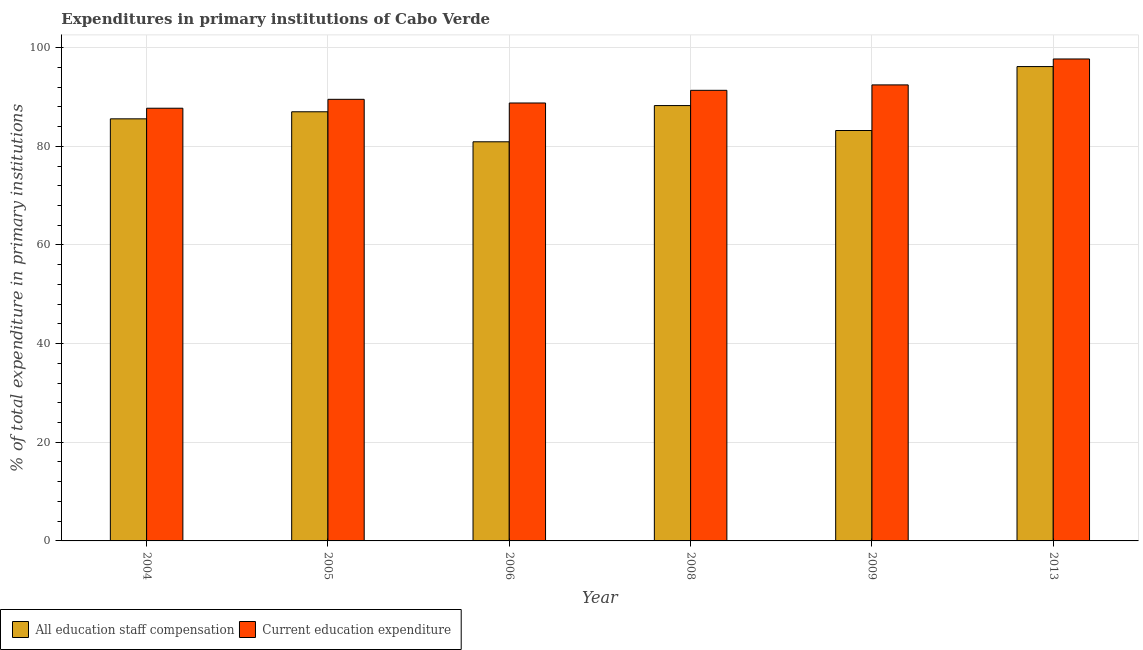How many groups of bars are there?
Your response must be concise. 6. How many bars are there on the 1st tick from the left?
Keep it short and to the point. 2. How many bars are there on the 6th tick from the right?
Make the answer very short. 2. What is the expenditure in staff compensation in 2006?
Your answer should be compact. 80.91. Across all years, what is the maximum expenditure in education?
Your response must be concise. 97.7. Across all years, what is the minimum expenditure in staff compensation?
Your answer should be very brief. 80.91. In which year was the expenditure in education maximum?
Your answer should be compact. 2013. In which year was the expenditure in education minimum?
Ensure brevity in your answer.  2004. What is the total expenditure in staff compensation in the graph?
Ensure brevity in your answer.  521.1. What is the difference between the expenditure in education in 2006 and that in 2013?
Offer a terse response. -8.92. What is the difference between the expenditure in staff compensation in 2006 and the expenditure in education in 2009?
Keep it short and to the point. -2.29. What is the average expenditure in education per year?
Keep it short and to the point. 91.25. In the year 2009, what is the difference between the expenditure in staff compensation and expenditure in education?
Provide a succinct answer. 0. What is the ratio of the expenditure in staff compensation in 2004 to that in 2006?
Your answer should be very brief. 1.06. Is the expenditure in education in 2008 less than that in 2013?
Give a very brief answer. Yes. Is the difference between the expenditure in staff compensation in 2004 and 2008 greater than the difference between the expenditure in education in 2004 and 2008?
Provide a succinct answer. No. What is the difference between the highest and the second highest expenditure in education?
Ensure brevity in your answer.  5.26. What is the difference between the highest and the lowest expenditure in education?
Provide a succinct answer. 9.98. Is the sum of the expenditure in staff compensation in 2009 and 2013 greater than the maximum expenditure in education across all years?
Your response must be concise. Yes. What does the 2nd bar from the left in 2013 represents?
Your answer should be compact. Current education expenditure. What does the 1st bar from the right in 2008 represents?
Offer a terse response. Current education expenditure. How many bars are there?
Provide a short and direct response. 12. How many years are there in the graph?
Provide a succinct answer. 6. What is the difference between two consecutive major ticks on the Y-axis?
Provide a short and direct response. 20. Does the graph contain any zero values?
Your answer should be compact. No. Does the graph contain grids?
Your answer should be compact. Yes. How many legend labels are there?
Your response must be concise. 2. What is the title of the graph?
Keep it short and to the point. Expenditures in primary institutions of Cabo Verde. Does "Agricultural land" appear as one of the legend labels in the graph?
Offer a very short reply. No. What is the label or title of the Y-axis?
Offer a very short reply. % of total expenditure in primary institutions. What is the % of total expenditure in primary institutions in All education staff compensation in 2004?
Make the answer very short. 85.57. What is the % of total expenditure in primary institutions in Current education expenditure in 2004?
Keep it short and to the point. 87.72. What is the % of total expenditure in primary institutions in All education staff compensation in 2005?
Offer a terse response. 87. What is the % of total expenditure in primary institutions in Current education expenditure in 2005?
Provide a short and direct response. 89.52. What is the % of total expenditure in primary institutions of All education staff compensation in 2006?
Keep it short and to the point. 80.91. What is the % of total expenditure in primary institutions of Current education expenditure in 2006?
Your response must be concise. 88.78. What is the % of total expenditure in primary institutions in All education staff compensation in 2008?
Ensure brevity in your answer.  88.26. What is the % of total expenditure in primary institutions in Current education expenditure in 2008?
Ensure brevity in your answer.  91.35. What is the % of total expenditure in primary institutions in All education staff compensation in 2009?
Your response must be concise. 83.2. What is the % of total expenditure in primary institutions in Current education expenditure in 2009?
Your answer should be very brief. 92.45. What is the % of total expenditure in primary institutions of All education staff compensation in 2013?
Your answer should be very brief. 96.16. What is the % of total expenditure in primary institutions in Current education expenditure in 2013?
Give a very brief answer. 97.7. Across all years, what is the maximum % of total expenditure in primary institutions of All education staff compensation?
Make the answer very short. 96.16. Across all years, what is the maximum % of total expenditure in primary institutions in Current education expenditure?
Offer a very short reply. 97.7. Across all years, what is the minimum % of total expenditure in primary institutions of All education staff compensation?
Your answer should be compact. 80.91. Across all years, what is the minimum % of total expenditure in primary institutions in Current education expenditure?
Your response must be concise. 87.72. What is the total % of total expenditure in primary institutions in All education staff compensation in the graph?
Your answer should be compact. 521.1. What is the total % of total expenditure in primary institutions of Current education expenditure in the graph?
Provide a short and direct response. 547.52. What is the difference between the % of total expenditure in primary institutions in All education staff compensation in 2004 and that in 2005?
Your answer should be very brief. -1.43. What is the difference between the % of total expenditure in primary institutions in Current education expenditure in 2004 and that in 2005?
Provide a short and direct response. -1.8. What is the difference between the % of total expenditure in primary institutions in All education staff compensation in 2004 and that in 2006?
Provide a short and direct response. 4.65. What is the difference between the % of total expenditure in primary institutions in Current education expenditure in 2004 and that in 2006?
Keep it short and to the point. -1.06. What is the difference between the % of total expenditure in primary institutions of All education staff compensation in 2004 and that in 2008?
Make the answer very short. -2.69. What is the difference between the % of total expenditure in primary institutions of Current education expenditure in 2004 and that in 2008?
Ensure brevity in your answer.  -3.63. What is the difference between the % of total expenditure in primary institutions of All education staff compensation in 2004 and that in 2009?
Offer a terse response. 2.37. What is the difference between the % of total expenditure in primary institutions of Current education expenditure in 2004 and that in 2009?
Your response must be concise. -4.73. What is the difference between the % of total expenditure in primary institutions of All education staff compensation in 2004 and that in 2013?
Provide a short and direct response. -10.6. What is the difference between the % of total expenditure in primary institutions in Current education expenditure in 2004 and that in 2013?
Provide a short and direct response. -9.98. What is the difference between the % of total expenditure in primary institutions of All education staff compensation in 2005 and that in 2006?
Make the answer very short. 6.09. What is the difference between the % of total expenditure in primary institutions in Current education expenditure in 2005 and that in 2006?
Provide a short and direct response. 0.74. What is the difference between the % of total expenditure in primary institutions in All education staff compensation in 2005 and that in 2008?
Offer a very short reply. -1.26. What is the difference between the % of total expenditure in primary institutions in Current education expenditure in 2005 and that in 2008?
Provide a succinct answer. -1.83. What is the difference between the % of total expenditure in primary institutions of All education staff compensation in 2005 and that in 2009?
Ensure brevity in your answer.  3.8. What is the difference between the % of total expenditure in primary institutions in Current education expenditure in 2005 and that in 2009?
Provide a succinct answer. -2.92. What is the difference between the % of total expenditure in primary institutions of All education staff compensation in 2005 and that in 2013?
Keep it short and to the point. -9.16. What is the difference between the % of total expenditure in primary institutions of Current education expenditure in 2005 and that in 2013?
Make the answer very short. -8.18. What is the difference between the % of total expenditure in primary institutions of All education staff compensation in 2006 and that in 2008?
Ensure brevity in your answer.  -7.34. What is the difference between the % of total expenditure in primary institutions in Current education expenditure in 2006 and that in 2008?
Offer a terse response. -2.57. What is the difference between the % of total expenditure in primary institutions in All education staff compensation in 2006 and that in 2009?
Offer a very short reply. -2.29. What is the difference between the % of total expenditure in primary institutions in Current education expenditure in 2006 and that in 2009?
Give a very brief answer. -3.67. What is the difference between the % of total expenditure in primary institutions of All education staff compensation in 2006 and that in 2013?
Ensure brevity in your answer.  -15.25. What is the difference between the % of total expenditure in primary institutions of Current education expenditure in 2006 and that in 2013?
Provide a succinct answer. -8.92. What is the difference between the % of total expenditure in primary institutions in All education staff compensation in 2008 and that in 2009?
Give a very brief answer. 5.06. What is the difference between the % of total expenditure in primary institutions of Current education expenditure in 2008 and that in 2009?
Offer a terse response. -1.1. What is the difference between the % of total expenditure in primary institutions of All education staff compensation in 2008 and that in 2013?
Make the answer very short. -7.91. What is the difference between the % of total expenditure in primary institutions in Current education expenditure in 2008 and that in 2013?
Keep it short and to the point. -6.35. What is the difference between the % of total expenditure in primary institutions of All education staff compensation in 2009 and that in 2013?
Ensure brevity in your answer.  -12.96. What is the difference between the % of total expenditure in primary institutions in Current education expenditure in 2009 and that in 2013?
Keep it short and to the point. -5.26. What is the difference between the % of total expenditure in primary institutions of All education staff compensation in 2004 and the % of total expenditure in primary institutions of Current education expenditure in 2005?
Your answer should be very brief. -3.96. What is the difference between the % of total expenditure in primary institutions of All education staff compensation in 2004 and the % of total expenditure in primary institutions of Current education expenditure in 2006?
Your response must be concise. -3.21. What is the difference between the % of total expenditure in primary institutions of All education staff compensation in 2004 and the % of total expenditure in primary institutions of Current education expenditure in 2008?
Make the answer very short. -5.78. What is the difference between the % of total expenditure in primary institutions of All education staff compensation in 2004 and the % of total expenditure in primary institutions of Current education expenditure in 2009?
Your response must be concise. -6.88. What is the difference between the % of total expenditure in primary institutions in All education staff compensation in 2004 and the % of total expenditure in primary institutions in Current education expenditure in 2013?
Offer a very short reply. -12.14. What is the difference between the % of total expenditure in primary institutions of All education staff compensation in 2005 and the % of total expenditure in primary institutions of Current education expenditure in 2006?
Offer a very short reply. -1.78. What is the difference between the % of total expenditure in primary institutions in All education staff compensation in 2005 and the % of total expenditure in primary institutions in Current education expenditure in 2008?
Offer a very short reply. -4.35. What is the difference between the % of total expenditure in primary institutions in All education staff compensation in 2005 and the % of total expenditure in primary institutions in Current education expenditure in 2009?
Offer a very short reply. -5.45. What is the difference between the % of total expenditure in primary institutions in All education staff compensation in 2005 and the % of total expenditure in primary institutions in Current education expenditure in 2013?
Give a very brief answer. -10.7. What is the difference between the % of total expenditure in primary institutions of All education staff compensation in 2006 and the % of total expenditure in primary institutions of Current education expenditure in 2008?
Provide a succinct answer. -10.44. What is the difference between the % of total expenditure in primary institutions of All education staff compensation in 2006 and the % of total expenditure in primary institutions of Current education expenditure in 2009?
Give a very brief answer. -11.53. What is the difference between the % of total expenditure in primary institutions in All education staff compensation in 2006 and the % of total expenditure in primary institutions in Current education expenditure in 2013?
Make the answer very short. -16.79. What is the difference between the % of total expenditure in primary institutions of All education staff compensation in 2008 and the % of total expenditure in primary institutions of Current education expenditure in 2009?
Your answer should be compact. -4.19. What is the difference between the % of total expenditure in primary institutions in All education staff compensation in 2008 and the % of total expenditure in primary institutions in Current education expenditure in 2013?
Your response must be concise. -9.45. What is the difference between the % of total expenditure in primary institutions in All education staff compensation in 2009 and the % of total expenditure in primary institutions in Current education expenditure in 2013?
Offer a very short reply. -14.5. What is the average % of total expenditure in primary institutions in All education staff compensation per year?
Provide a succinct answer. 86.85. What is the average % of total expenditure in primary institutions of Current education expenditure per year?
Ensure brevity in your answer.  91.25. In the year 2004, what is the difference between the % of total expenditure in primary institutions in All education staff compensation and % of total expenditure in primary institutions in Current education expenditure?
Your answer should be compact. -2.15. In the year 2005, what is the difference between the % of total expenditure in primary institutions in All education staff compensation and % of total expenditure in primary institutions in Current education expenditure?
Offer a terse response. -2.52. In the year 2006, what is the difference between the % of total expenditure in primary institutions of All education staff compensation and % of total expenditure in primary institutions of Current education expenditure?
Your response must be concise. -7.87. In the year 2008, what is the difference between the % of total expenditure in primary institutions of All education staff compensation and % of total expenditure in primary institutions of Current education expenditure?
Keep it short and to the point. -3.09. In the year 2009, what is the difference between the % of total expenditure in primary institutions in All education staff compensation and % of total expenditure in primary institutions in Current education expenditure?
Offer a terse response. -9.24. In the year 2013, what is the difference between the % of total expenditure in primary institutions in All education staff compensation and % of total expenditure in primary institutions in Current education expenditure?
Ensure brevity in your answer.  -1.54. What is the ratio of the % of total expenditure in primary institutions of All education staff compensation in 2004 to that in 2005?
Provide a succinct answer. 0.98. What is the ratio of the % of total expenditure in primary institutions of Current education expenditure in 2004 to that in 2005?
Offer a terse response. 0.98. What is the ratio of the % of total expenditure in primary institutions of All education staff compensation in 2004 to that in 2006?
Keep it short and to the point. 1.06. What is the ratio of the % of total expenditure in primary institutions of All education staff compensation in 2004 to that in 2008?
Your answer should be very brief. 0.97. What is the ratio of the % of total expenditure in primary institutions in Current education expenditure in 2004 to that in 2008?
Your response must be concise. 0.96. What is the ratio of the % of total expenditure in primary institutions of All education staff compensation in 2004 to that in 2009?
Your answer should be very brief. 1.03. What is the ratio of the % of total expenditure in primary institutions in Current education expenditure in 2004 to that in 2009?
Your response must be concise. 0.95. What is the ratio of the % of total expenditure in primary institutions in All education staff compensation in 2004 to that in 2013?
Provide a succinct answer. 0.89. What is the ratio of the % of total expenditure in primary institutions in Current education expenditure in 2004 to that in 2013?
Make the answer very short. 0.9. What is the ratio of the % of total expenditure in primary institutions in All education staff compensation in 2005 to that in 2006?
Provide a succinct answer. 1.08. What is the ratio of the % of total expenditure in primary institutions in Current education expenditure in 2005 to that in 2006?
Your answer should be very brief. 1.01. What is the ratio of the % of total expenditure in primary institutions of All education staff compensation in 2005 to that in 2008?
Provide a short and direct response. 0.99. What is the ratio of the % of total expenditure in primary institutions in Current education expenditure in 2005 to that in 2008?
Your answer should be compact. 0.98. What is the ratio of the % of total expenditure in primary institutions of All education staff compensation in 2005 to that in 2009?
Ensure brevity in your answer.  1.05. What is the ratio of the % of total expenditure in primary institutions of Current education expenditure in 2005 to that in 2009?
Your response must be concise. 0.97. What is the ratio of the % of total expenditure in primary institutions of All education staff compensation in 2005 to that in 2013?
Offer a terse response. 0.9. What is the ratio of the % of total expenditure in primary institutions of Current education expenditure in 2005 to that in 2013?
Make the answer very short. 0.92. What is the ratio of the % of total expenditure in primary institutions in All education staff compensation in 2006 to that in 2008?
Provide a short and direct response. 0.92. What is the ratio of the % of total expenditure in primary institutions of Current education expenditure in 2006 to that in 2008?
Keep it short and to the point. 0.97. What is the ratio of the % of total expenditure in primary institutions in All education staff compensation in 2006 to that in 2009?
Your answer should be compact. 0.97. What is the ratio of the % of total expenditure in primary institutions in Current education expenditure in 2006 to that in 2009?
Provide a succinct answer. 0.96. What is the ratio of the % of total expenditure in primary institutions of All education staff compensation in 2006 to that in 2013?
Your answer should be very brief. 0.84. What is the ratio of the % of total expenditure in primary institutions of Current education expenditure in 2006 to that in 2013?
Ensure brevity in your answer.  0.91. What is the ratio of the % of total expenditure in primary institutions of All education staff compensation in 2008 to that in 2009?
Your response must be concise. 1.06. What is the ratio of the % of total expenditure in primary institutions of Current education expenditure in 2008 to that in 2009?
Provide a succinct answer. 0.99. What is the ratio of the % of total expenditure in primary institutions in All education staff compensation in 2008 to that in 2013?
Offer a very short reply. 0.92. What is the ratio of the % of total expenditure in primary institutions of Current education expenditure in 2008 to that in 2013?
Your answer should be compact. 0.94. What is the ratio of the % of total expenditure in primary institutions of All education staff compensation in 2009 to that in 2013?
Provide a succinct answer. 0.87. What is the ratio of the % of total expenditure in primary institutions in Current education expenditure in 2009 to that in 2013?
Your answer should be compact. 0.95. What is the difference between the highest and the second highest % of total expenditure in primary institutions of All education staff compensation?
Your answer should be very brief. 7.91. What is the difference between the highest and the second highest % of total expenditure in primary institutions in Current education expenditure?
Provide a short and direct response. 5.26. What is the difference between the highest and the lowest % of total expenditure in primary institutions of All education staff compensation?
Your answer should be compact. 15.25. What is the difference between the highest and the lowest % of total expenditure in primary institutions of Current education expenditure?
Your answer should be very brief. 9.98. 